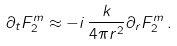<formula> <loc_0><loc_0><loc_500><loc_500>\partial _ { t } F _ { 2 } ^ { m } \approx - i \, \frac { k } { 4 \pi r ^ { 2 } } \partial _ { r } F _ { 2 } ^ { m } \, .</formula> 